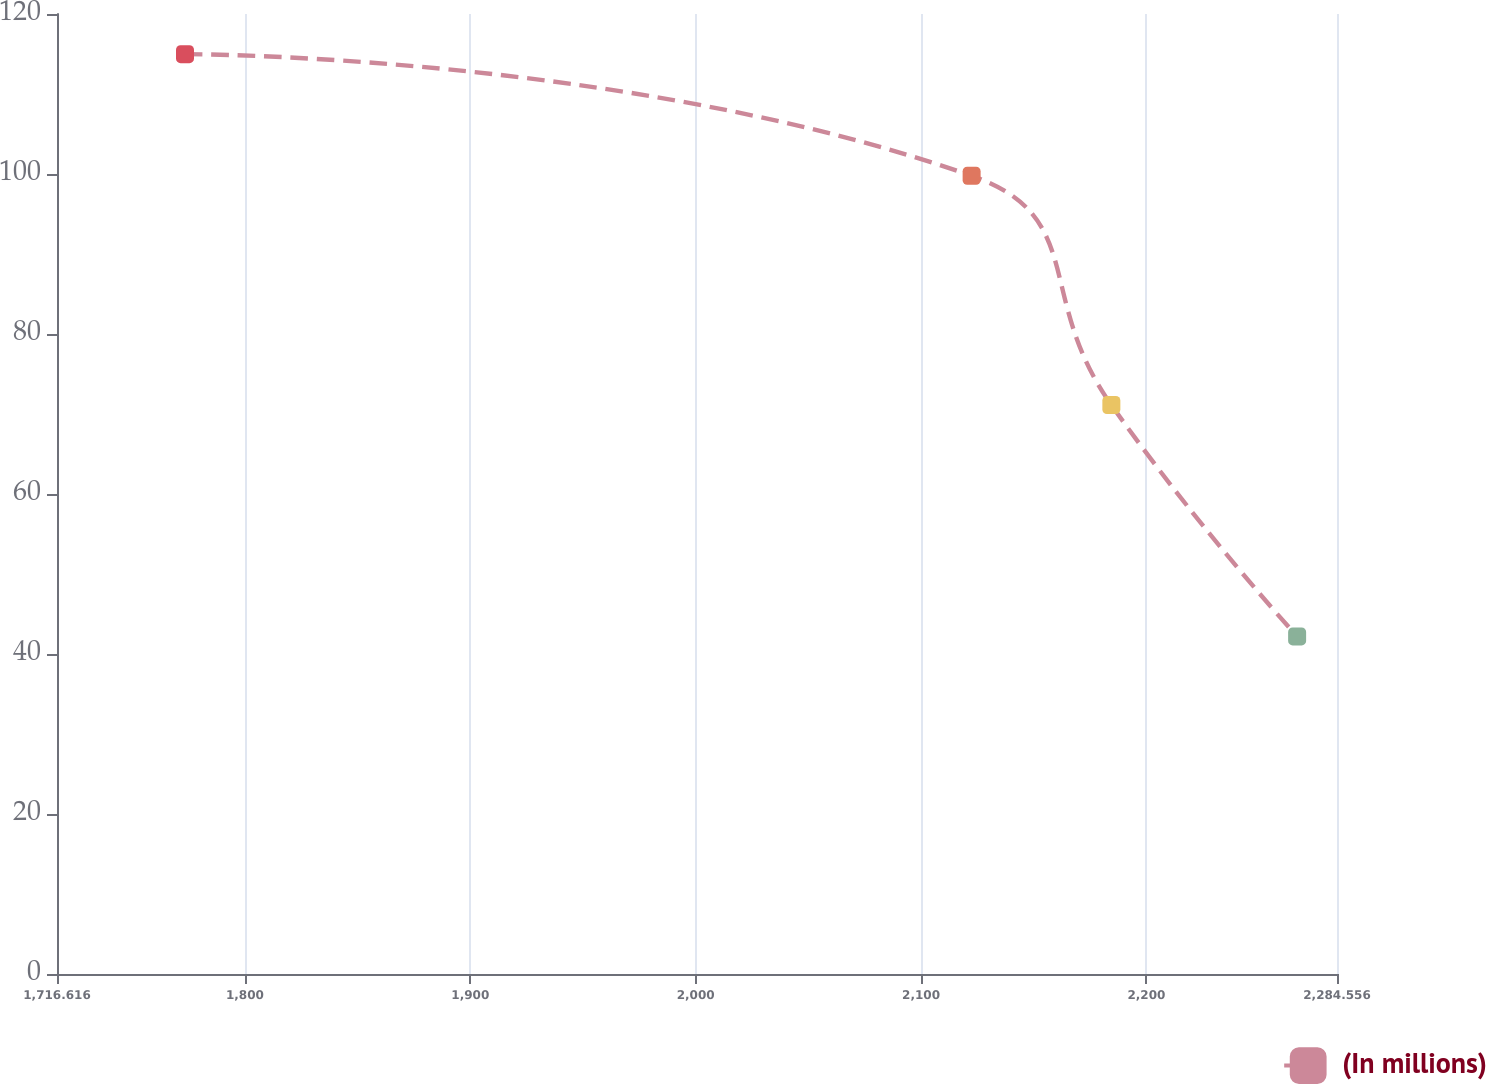Convert chart. <chart><loc_0><loc_0><loc_500><loc_500><line_chart><ecel><fcel>(In millions)<nl><fcel>1773.41<fcel>114.98<nl><fcel>2122.44<fcel>99.78<nl><fcel>2184.44<fcel>71.12<nl><fcel>2266.86<fcel>42.2<nl><fcel>2341.35<fcel>25.17<nl></chart> 